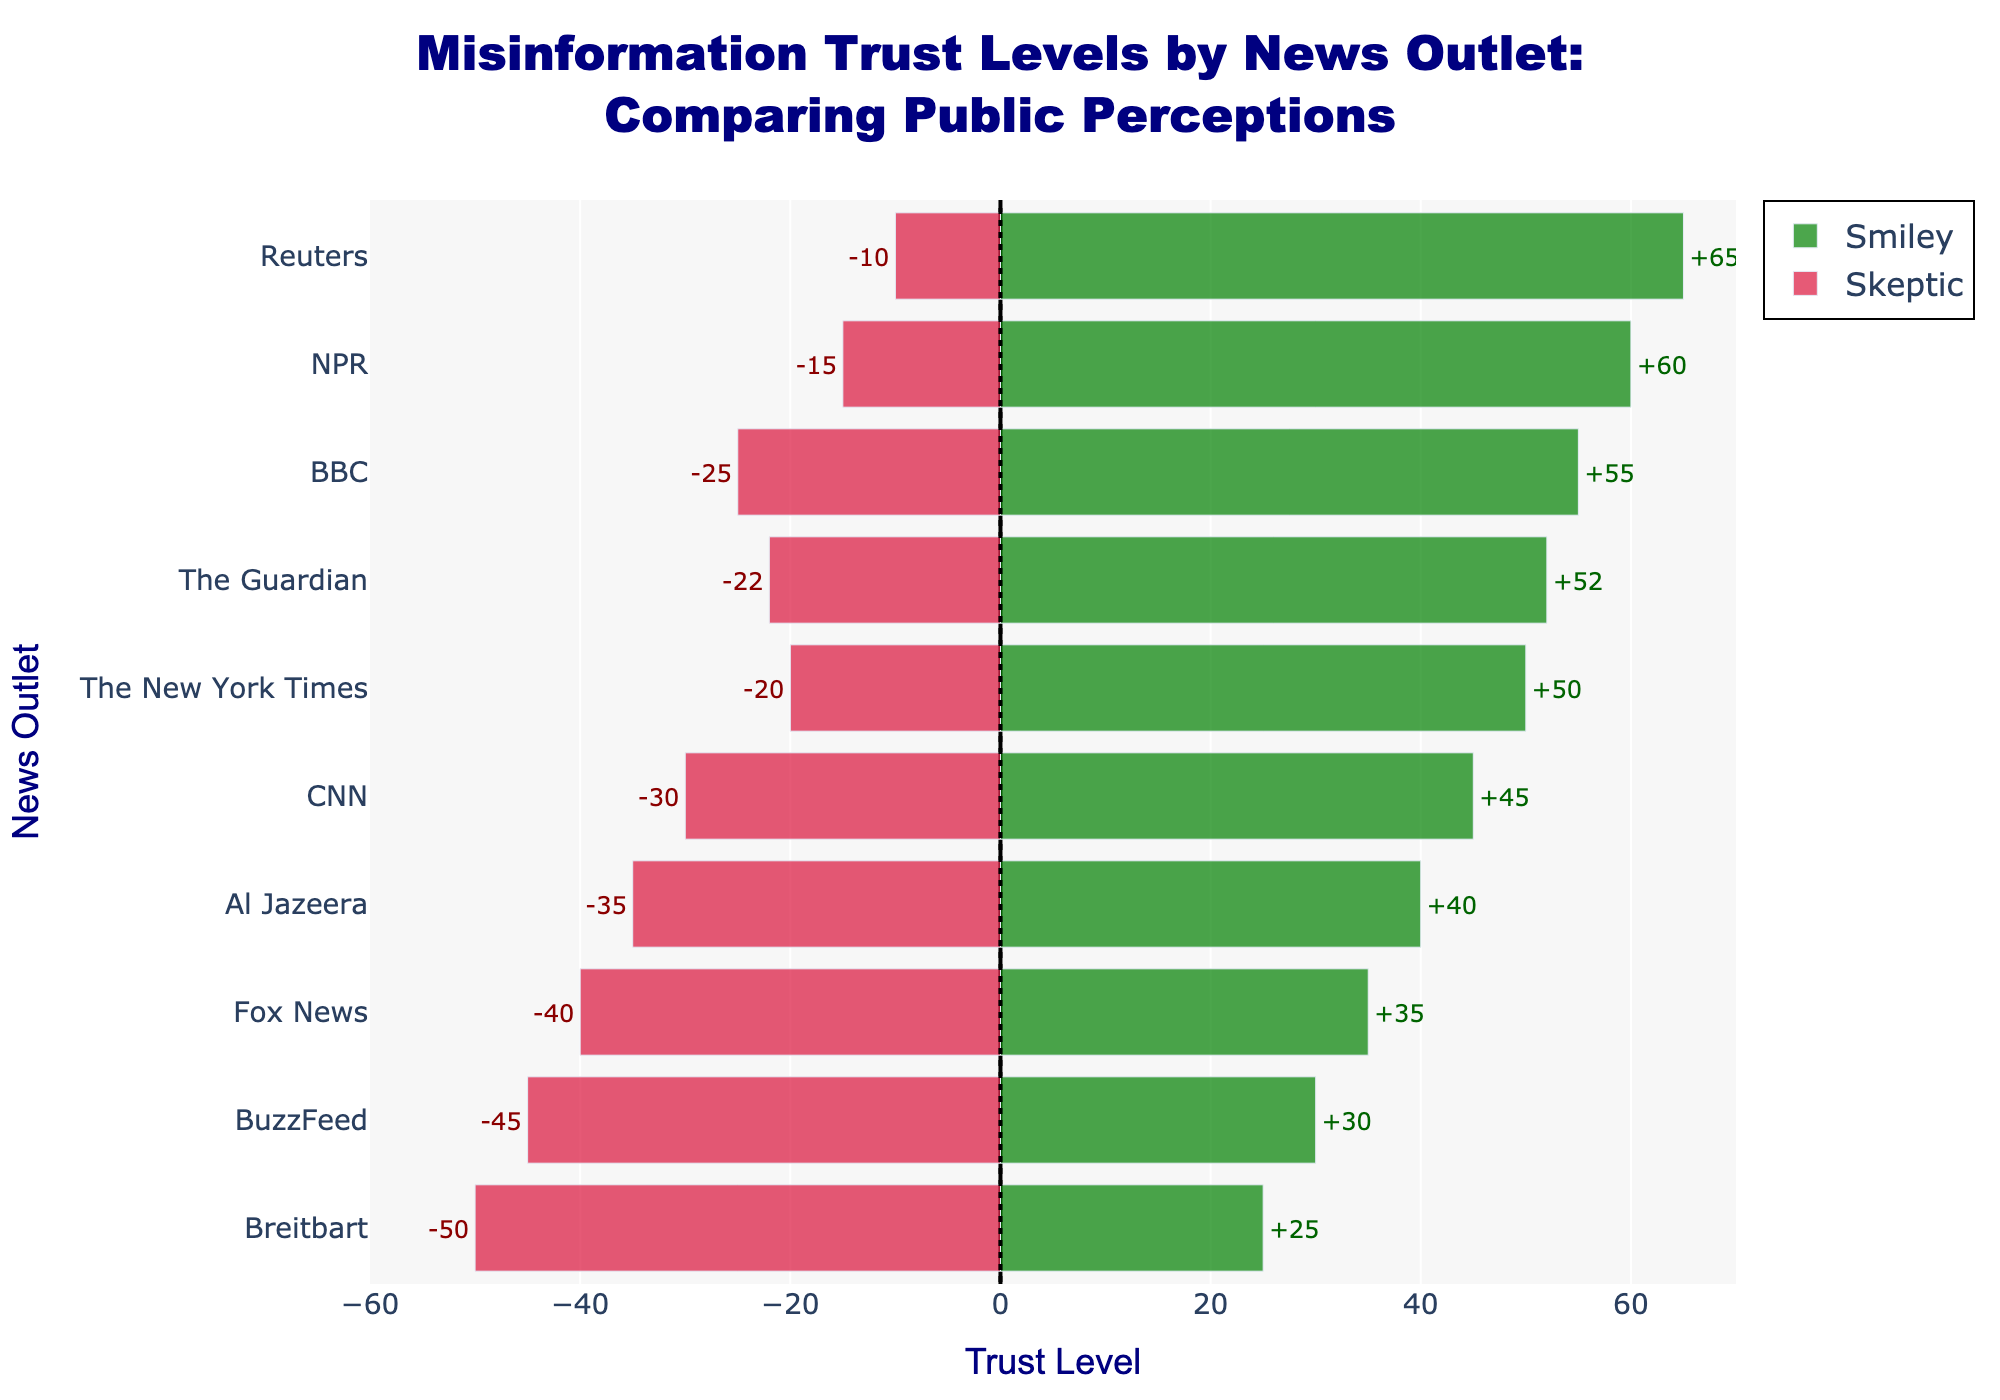Which news outlet has the highest trust level from the Smiley perception? Look at the bars for the Smiley perception and see which has the longest green bar. Reuters has the highest trust level, marked at 65.
Answer: Reuters Which news outlet has the lowest trust level from the Skeptic perception? Observe the red bars for the Skeptic perception and find the one extending the furthest to the left. Breitbart has the lowest trust level, marked at -50.
Answer: Breitbart What's the difference in trust levels for CNN between the Smiley and Skeptic perceptions? Check CNN's Smiley trust level at 45 and CNN's Skeptic trust level at -30. Subtract the Skeptic trust level from the Smiley trust level (45 - (-30) = 75).
Answer: 75 Which news outlet shows a larger difference in trust levels: NPR or BuzzFeed? For NPR, the Smiley trust level is 60, and the Skeptic is -15, resulting in a difference of 75. For BuzzFeed, the Smiley trust level is 30, and the Skeptic is -45, resulting in a difference of 75.
Answer: Both show equal difference How many outlets have a Smiley trust level above 50? Count the green bars that start at 50 or higher. BBC, The New York Times, The Guardian, NPR, and Reuters are the ones, totaling 5.
Answer: 5 Between CNN and Fox News, which outlet has a more negative Skeptic perception? Compare the length of the red bars for CNN (-30) and Fox News (-40). Fox News has a more negative value.
Answer: Fox News Which outlet has the closest trust levels in both perceptions? Look for similar lengths of green and red bars. The New York Times has Smiley at 50 and Skeptic at -20, a difference of 70. The next closest are many that have other differences, but none are closer.
Answer: The New York Times What is the average Smiley trust level across all news outlets? Average the Smiley trust levels: (45 + 55 + 35 + 50 + 52 + 25 + 60 + 40 + 30 + 65) / 10. The result is (457.5) / 10 = 50.75.
Answer: 50.75 Between the most and least trusted outlets by the Smiley perception, what's the difference in their trust levels? The most trusted is Reuters at 65, and the least is Breitbart at 25. Subtract 25 from 65 (65 - 25 = 40).
Answer: 40 